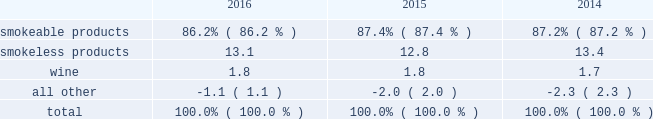The relative percentages of operating companies income ( loss ) attributable to each reportable segment and the all other category were as follows: .
For items affecting the comparability of the relative percentages of operating companies income ( loss ) attributable to each reportable segment , see note 16 .
Narrative description of business portions of the information called for by this item are included in operating results by business segment in item 7 .
Management 2019s discussion and analysis of financial condition and results of operations of this annual report on form 10-k ( 201citem 7 201d ) .
Tobacco space altria group , inc . 2019s tobacco operating companies include pm usa , usstc and other subsidiaries of ust , middleton , nu mark and nat sherman .
Altria group distribution company provides sales , distribution and consumer engagement services to altria group , inc . 2019s tobacco operating companies .
The products of altria group , inc . 2019s tobacco subsidiaries include smokeable tobacco products , consisting of cigarettes manufactured and sold by pm usa and nat sherman , machine- made large cigars and pipe tobacco manufactured and sold by middleton and premium cigars sold by nat sherman ; smokeless tobacco products manufactured and sold by usstc ; and innovative tobacco products , including e-vapor products manufactured and sold by nu mark .
Cigarettes : pm usa is the largest cigarette company in the united states , with total cigarette shipment volume in the united states of approximately 122.9 billion units in 2016 , a decrease of 2.5% ( 2.5 % ) from 2015 .
Marlboro , the principal cigarette brand of pm usa , has been the largest-selling cigarette brand in the united states for over 40 years .
Nat sherman sells substantially all of its super-premium cigarettes in the united states .
Cigars : middleton is engaged in the manufacture and sale of machine-made large cigars and pipe tobacco to customers , substantially all of which are located in the united states .
Middleton sources a portion of its cigars from an importer through a third-party contract manufacturing arrangement .
Total shipment volume for cigars was approximately 1.4 billion units in 2016 , an increase of 5.9% ( 5.9 % ) from 2015 .
Black & mild is the principal cigar brand of middleton .
Nat sherman sources its premium cigars from importers through third-party contract manufacturing arrangements and sells substantially all of its cigars in the united states .
Smokeless tobacco products : usstc is the leading producer and marketer of moist smokeless tobacco ( 201cmst 201d ) products .
The smokeless products segment includes the premium brands , copenhagen and skoal , and value brands , red seal and husky .
Substantially all of the smokeless tobacco products are manufactured and sold to customers in the united states .
Total smokeless products shipment volume was 853.5 million units in 2016 , an increase of 4.9% ( 4.9 % ) from 2015 .
Innovative tobacco products : nu mark participates in the e-vapor category and has developed and commercialized other innovative tobacco products .
In addition , nu mark sources the production of its e-vapor products through overseas contract manufacturing arrangements .
In 2013 , nu mark introduced markten e-vapor products .
In april 2014 , nu mark acquired the e-vapor business of green smoke , inc .
And its affiliates ( 201cgreen smoke 201d ) , which began selling e-vapor products in 2009 .
For a further discussion of the acquisition of green smoke , see note 3 .
Acquisition of green smoke to the consolidated financial statements in item 8 ( 201cnote 3 201d ) .
In december 2013 , altria group , inc . 2019s subsidiaries entered into a series of agreements with philip morris international inc .
( 201cpmi 201d ) pursuant to which altria group , inc . 2019s subsidiaries provide an exclusive license to pmi to sell nu mark 2019s e-vapor products outside the united states , and pmi 2019s subsidiaries provide an exclusive license to altria group , inc . 2019s subsidiaries to sell two of pmi 2019s heated tobacco product platforms in the united states .
Further , in july 2015 , altria group , inc .
Announced the expansion of its strategic framework with pmi to include a joint research , development and technology-sharing agreement .
Under this agreement , altria group , inc . 2019s subsidiaries and pmi will collaborate to develop e-vapor products for commercialization in the united states by altria group , inc . 2019s subsidiaries and in markets outside the united states by pmi .
This agreement also provides for exclusive technology cross licenses , technical information sharing and cooperation on scientific assessment , regulatory engagement and approval related to e-vapor products .
In the fourth quarter of 2016 , pmi submitted a modified risk tobacco product ( 201cmrtp 201d ) application for an electronically heated tobacco product with the united states food and drug administration 2019s ( 201cfda 201d ) center for tobacco products and announced that it plans to file its corresponding pre-market tobacco product application during the first quarter of 2017 .
The fda must determine whether to accept the applications for substantive review .
Upon regulatory authorization by the fda , altria group , inc . 2019s subsidiaries will have an exclusive license to sell this heated tobacco product in the united states .
Distribution , competition and raw materials : altria group , inc . 2019s tobacco subsidiaries sell their tobacco products principally to wholesalers ( including distributors ) , large retail organizations , including chain stores , and the armed services .
The market for tobacco products is highly competitive , characterized by brand recognition and loyalty , with product quality , taste , price , product innovation , marketing , packaging and distribution constituting the significant methods of competition .
Promotional activities include , in certain instances and where .
What is the total units of shipment volume for smokeless products in 2015 , in millions? 
Computations: (853.5 / (100 + 4.9%))
Answer: 8.53082. 